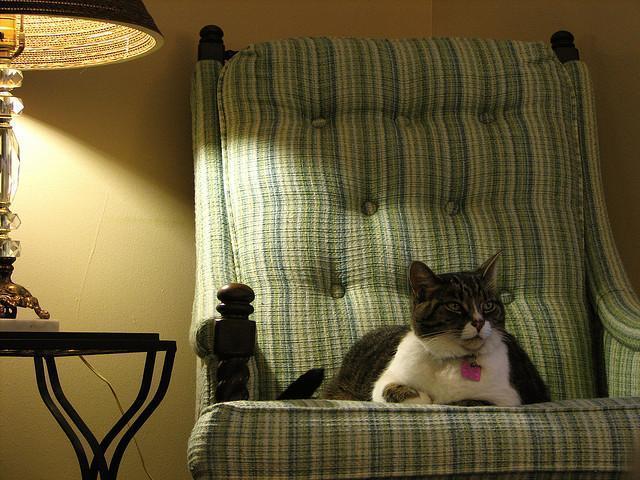How many keyboards are visible?
Give a very brief answer. 0. 